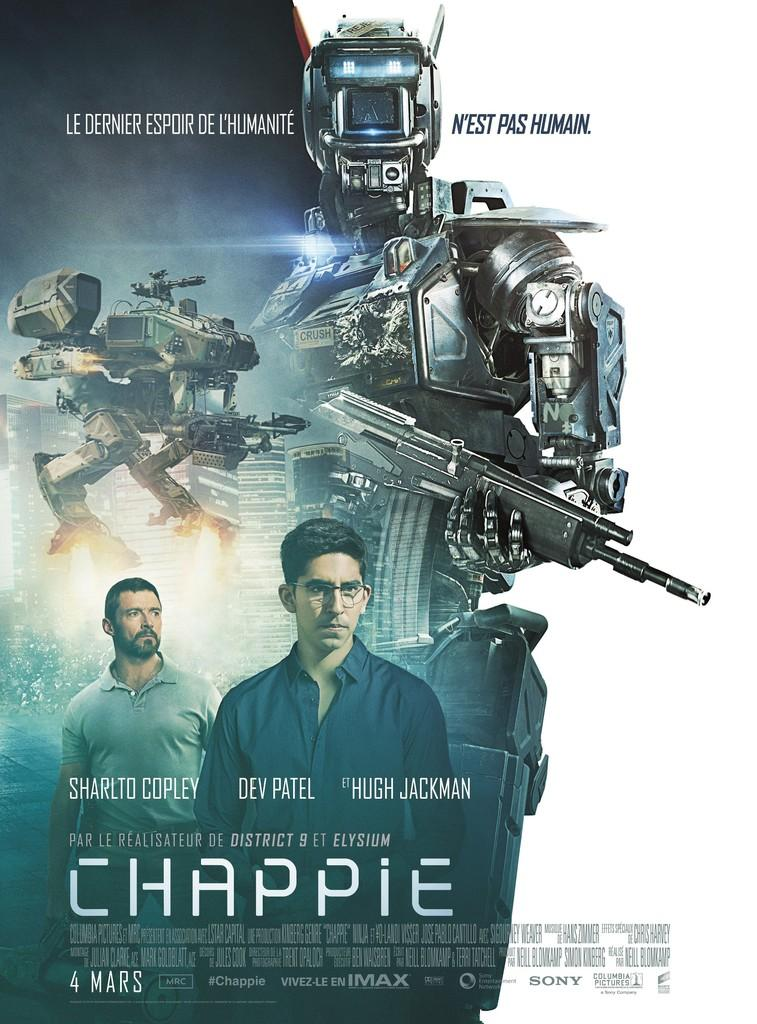<image>
Describe the image concisely. a movie poster for a film called Chappie 